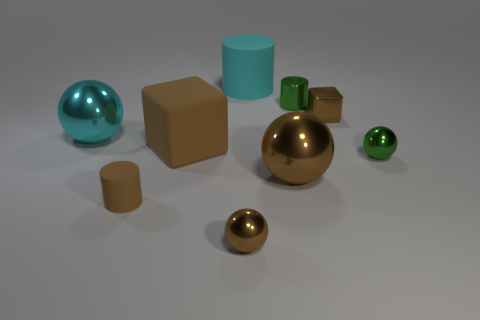Subtract all matte cylinders. How many cylinders are left? 1 Subtract all brown balls. How many balls are left? 2 Subtract 4 balls. How many balls are left? 0 Add 3 large rubber objects. How many large rubber objects are left? 5 Add 5 purple matte objects. How many purple matte objects exist? 5 Subtract 1 brown cylinders. How many objects are left? 8 Subtract all cylinders. How many objects are left? 6 Subtract all green cylinders. Subtract all brown cubes. How many cylinders are left? 2 Subtract all purple cubes. How many gray balls are left? 0 Subtract all green shiny cylinders. Subtract all large brown spheres. How many objects are left? 7 